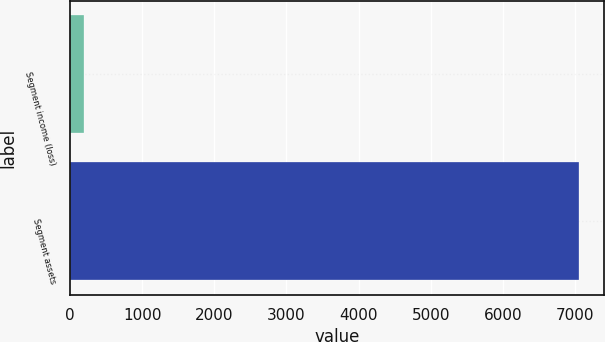Convert chart to OTSL. <chart><loc_0><loc_0><loc_500><loc_500><bar_chart><fcel>Segment income (loss)<fcel>Segment assets<nl><fcel>191<fcel>7050<nl></chart> 